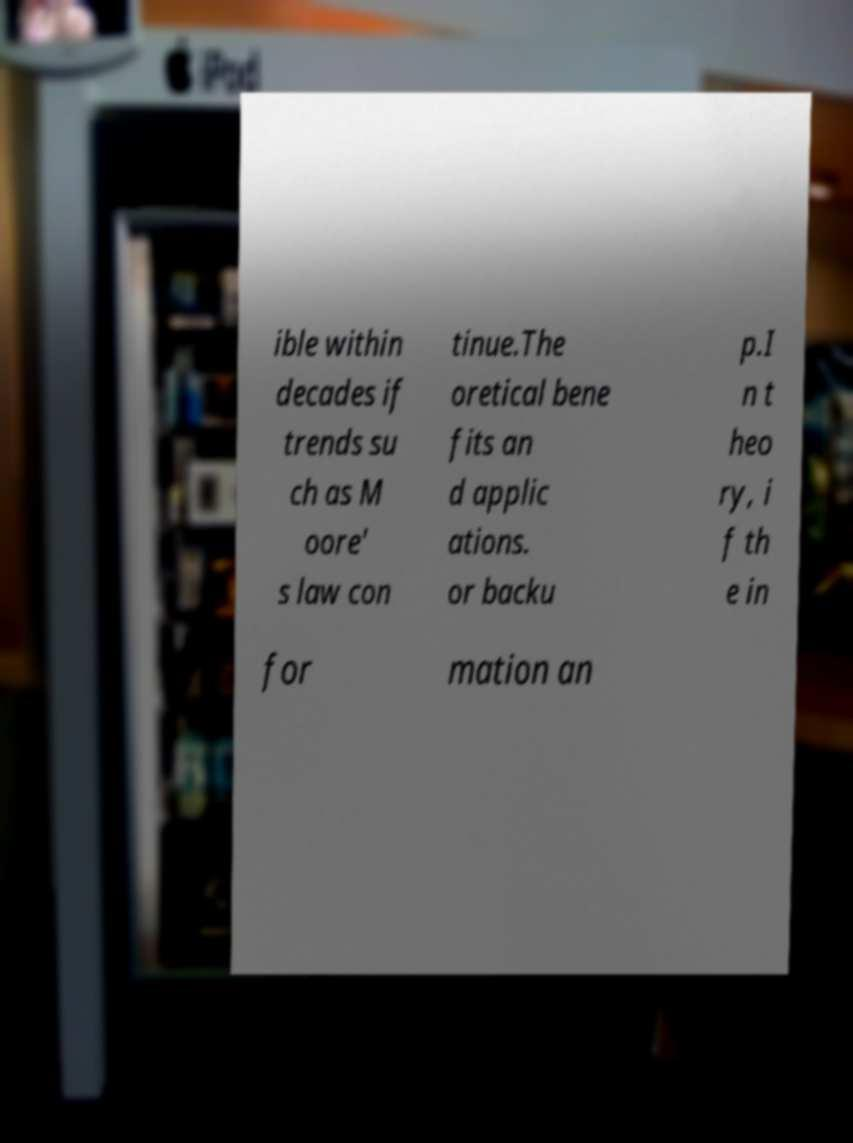Could you assist in decoding the text presented in this image and type it out clearly? ible within decades if trends su ch as M oore' s law con tinue.The oretical bene fits an d applic ations. or backu p.I n t heo ry, i f th e in for mation an 